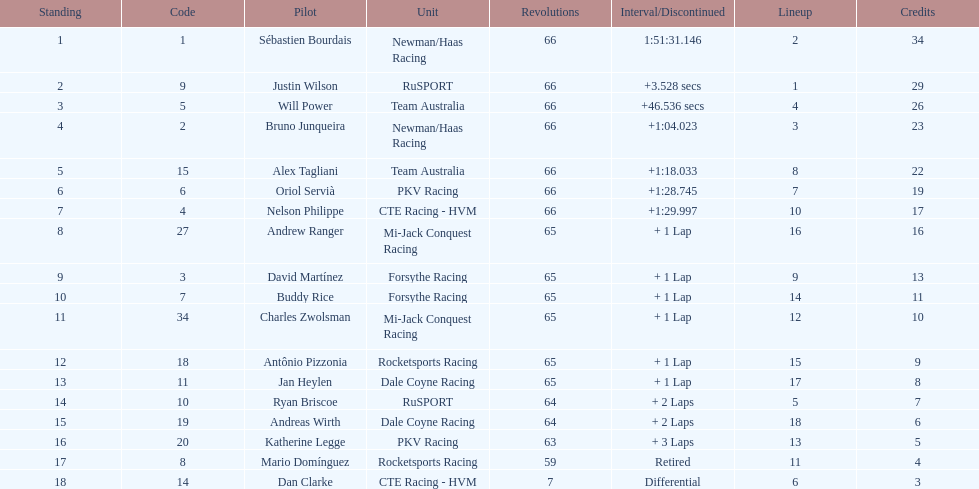At the 2006 gran premio telmex, did oriol servia or katherine legge complete more laps? Oriol Servià. 